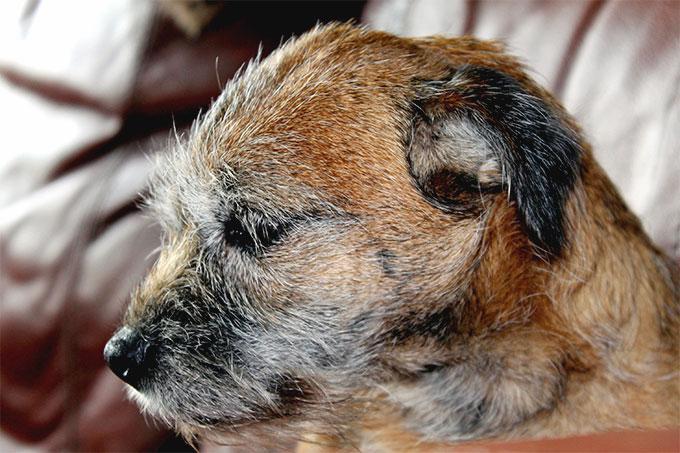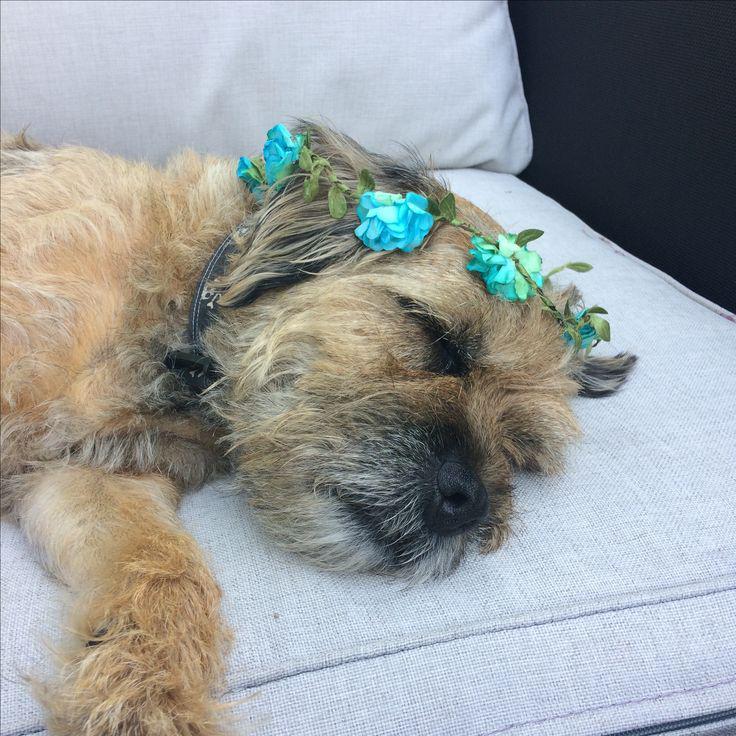The first image is the image on the left, the second image is the image on the right. For the images shown, is this caption "One image shows two dogs with their heads close together." true? Answer yes or no. No. The first image is the image on the left, the second image is the image on the right. For the images displayed, is the sentence "There is only one dog in each picture." factually correct? Answer yes or no. Yes. 